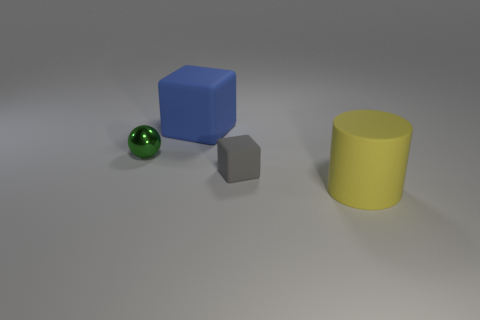Subtract all spheres. How many objects are left? 3 Add 1 large blue blocks. How many objects exist? 5 Subtract all gray spheres. Subtract all purple blocks. How many spheres are left? 1 Subtract all tiny gray matte objects. Subtract all small rubber cubes. How many objects are left? 2 Add 4 rubber cylinders. How many rubber cylinders are left? 5 Add 2 gray metallic cylinders. How many gray metallic cylinders exist? 2 Subtract 0 brown blocks. How many objects are left? 4 